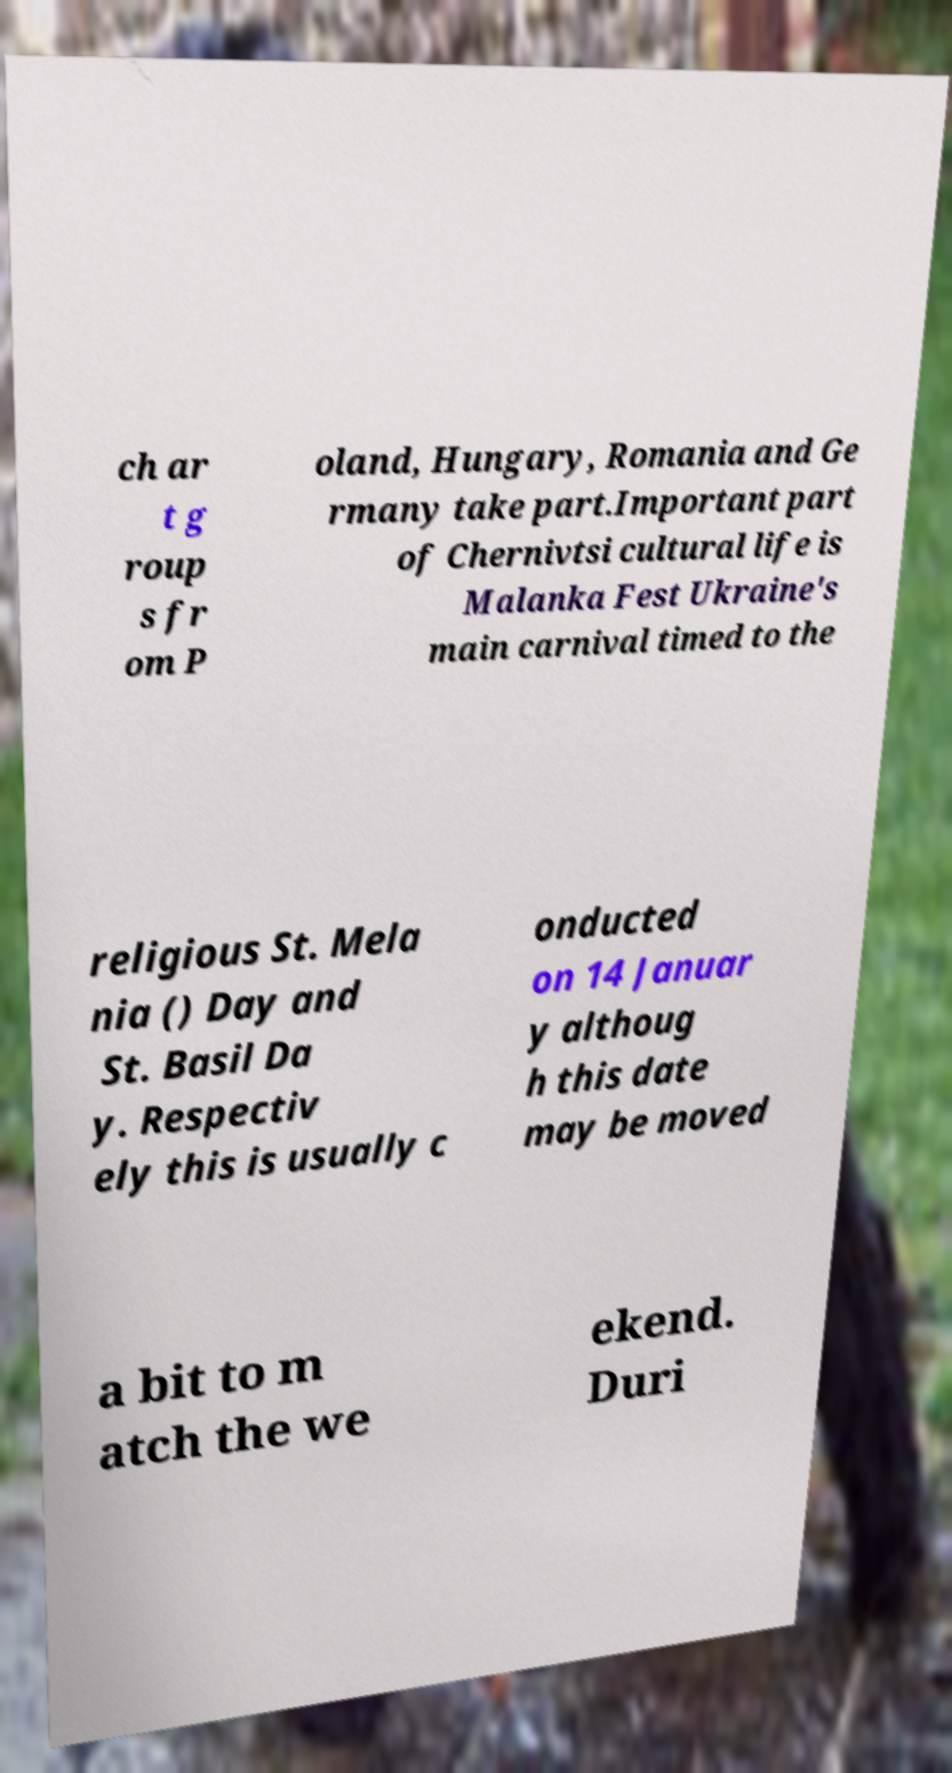Could you assist in decoding the text presented in this image and type it out clearly? ch ar t g roup s fr om P oland, Hungary, Romania and Ge rmany take part.Important part of Chernivtsi cultural life is Malanka Fest Ukraine's main carnival timed to the religious St. Mela nia () Day and St. Basil Da y. Respectiv ely this is usually c onducted on 14 Januar y althoug h this date may be moved a bit to m atch the we ekend. Duri 